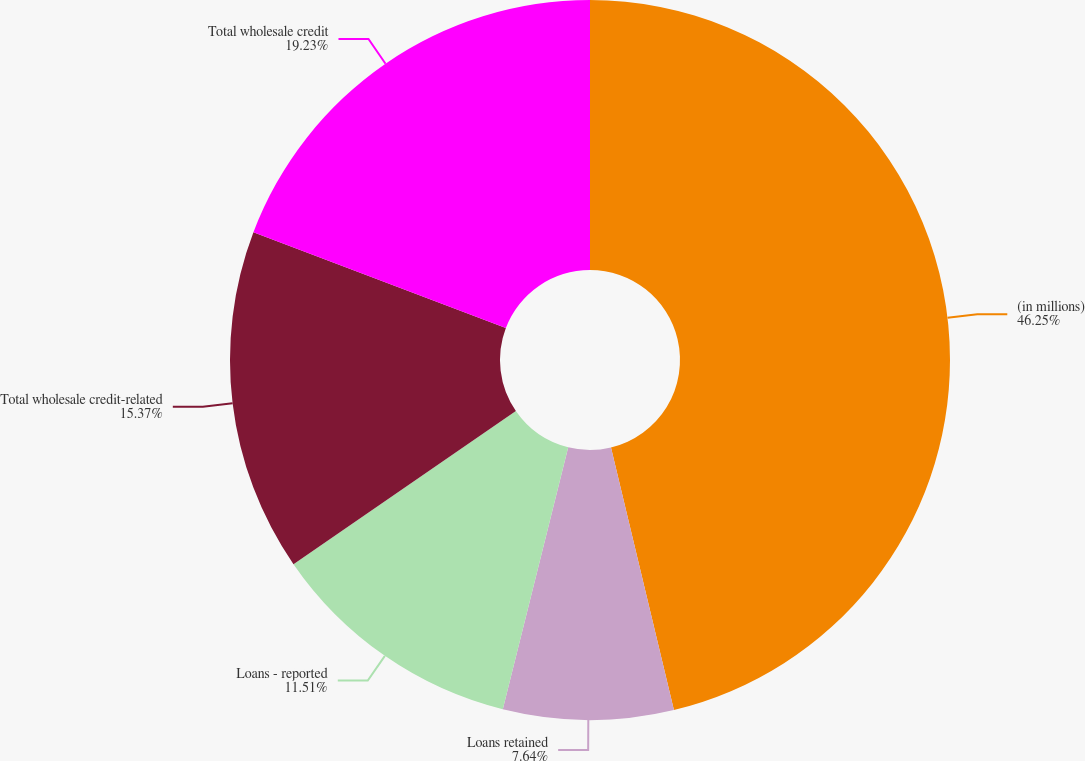<chart> <loc_0><loc_0><loc_500><loc_500><pie_chart><fcel>(in millions)<fcel>Loans retained<fcel>Loans - reported<fcel>Total wholesale credit-related<fcel>Total wholesale credit<nl><fcel>46.26%<fcel>7.64%<fcel>11.51%<fcel>15.37%<fcel>19.23%<nl></chart> 